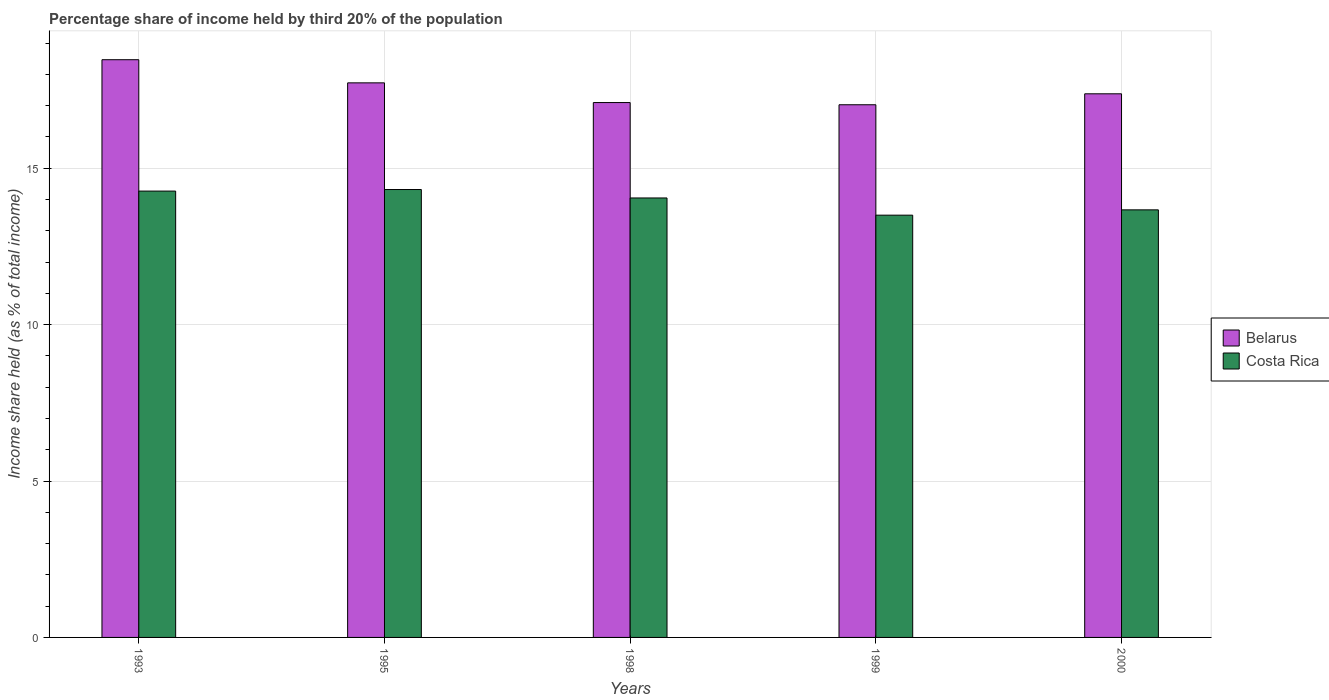How many different coloured bars are there?
Keep it short and to the point. 2. How many bars are there on the 3rd tick from the right?
Keep it short and to the point. 2. What is the label of the 3rd group of bars from the left?
Offer a very short reply. 1998. What is the share of income held by third 20% of the population in Belarus in 1998?
Ensure brevity in your answer.  17.1. Across all years, what is the maximum share of income held by third 20% of the population in Belarus?
Keep it short and to the point. 18.47. Across all years, what is the minimum share of income held by third 20% of the population in Costa Rica?
Ensure brevity in your answer.  13.5. In which year was the share of income held by third 20% of the population in Belarus maximum?
Your answer should be compact. 1993. What is the total share of income held by third 20% of the population in Belarus in the graph?
Give a very brief answer. 87.71. What is the difference between the share of income held by third 20% of the population in Costa Rica in 1993 and that in 1999?
Provide a short and direct response. 0.77. What is the difference between the share of income held by third 20% of the population in Belarus in 1993 and the share of income held by third 20% of the population in Costa Rica in 1995?
Provide a short and direct response. 4.15. What is the average share of income held by third 20% of the population in Belarus per year?
Keep it short and to the point. 17.54. In the year 1999, what is the difference between the share of income held by third 20% of the population in Belarus and share of income held by third 20% of the population in Costa Rica?
Make the answer very short. 3.53. What is the ratio of the share of income held by third 20% of the population in Belarus in 1993 to that in 1998?
Give a very brief answer. 1.08. Is the share of income held by third 20% of the population in Belarus in 1999 less than that in 2000?
Offer a very short reply. Yes. Is the difference between the share of income held by third 20% of the population in Belarus in 1993 and 1998 greater than the difference between the share of income held by third 20% of the population in Costa Rica in 1993 and 1998?
Provide a short and direct response. Yes. What is the difference between the highest and the second highest share of income held by third 20% of the population in Belarus?
Your answer should be compact. 0.74. What is the difference between the highest and the lowest share of income held by third 20% of the population in Belarus?
Your answer should be very brief. 1.44. In how many years, is the share of income held by third 20% of the population in Belarus greater than the average share of income held by third 20% of the population in Belarus taken over all years?
Make the answer very short. 2. Is the sum of the share of income held by third 20% of the population in Costa Rica in 1993 and 2000 greater than the maximum share of income held by third 20% of the population in Belarus across all years?
Your answer should be compact. Yes. What does the 1st bar from the left in 2000 represents?
Give a very brief answer. Belarus. What does the 2nd bar from the right in 1993 represents?
Offer a terse response. Belarus. How many bars are there?
Your answer should be compact. 10. What is the difference between two consecutive major ticks on the Y-axis?
Ensure brevity in your answer.  5. Does the graph contain grids?
Give a very brief answer. Yes. What is the title of the graph?
Make the answer very short. Percentage share of income held by third 20% of the population. What is the label or title of the Y-axis?
Offer a terse response. Income share held (as % of total income). What is the Income share held (as % of total income) in Belarus in 1993?
Your answer should be very brief. 18.47. What is the Income share held (as % of total income) in Costa Rica in 1993?
Provide a succinct answer. 14.27. What is the Income share held (as % of total income) of Belarus in 1995?
Your response must be concise. 17.73. What is the Income share held (as % of total income) in Costa Rica in 1995?
Give a very brief answer. 14.32. What is the Income share held (as % of total income) in Costa Rica in 1998?
Offer a terse response. 14.05. What is the Income share held (as % of total income) in Belarus in 1999?
Offer a very short reply. 17.03. What is the Income share held (as % of total income) in Belarus in 2000?
Your response must be concise. 17.38. What is the Income share held (as % of total income) of Costa Rica in 2000?
Give a very brief answer. 13.67. Across all years, what is the maximum Income share held (as % of total income) of Belarus?
Give a very brief answer. 18.47. Across all years, what is the maximum Income share held (as % of total income) in Costa Rica?
Your answer should be compact. 14.32. Across all years, what is the minimum Income share held (as % of total income) of Belarus?
Your answer should be compact. 17.03. Across all years, what is the minimum Income share held (as % of total income) of Costa Rica?
Provide a short and direct response. 13.5. What is the total Income share held (as % of total income) in Belarus in the graph?
Your answer should be very brief. 87.71. What is the total Income share held (as % of total income) in Costa Rica in the graph?
Your response must be concise. 69.81. What is the difference between the Income share held (as % of total income) of Belarus in 1993 and that in 1995?
Provide a short and direct response. 0.74. What is the difference between the Income share held (as % of total income) of Belarus in 1993 and that in 1998?
Your response must be concise. 1.37. What is the difference between the Income share held (as % of total income) of Costa Rica in 1993 and that in 1998?
Provide a short and direct response. 0.22. What is the difference between the Income share held (as % of total income) of Belarus in 1993 and that in 1999?
Your response must be concise. 1.44. What is the difference between the Income share held (as % of total income) of Costa Rica in 1993 and that in 1999?
Offer a terse response. 0.77. What is the difference between the Income share held (as % of total income) of Belarus in 1993 and that in 2000?
Ensure brevity in your answer.  1.09. What is the difference between the Income share held (as % of total income) in Belarus in 1995 and that in 1998?
Ensure brevity in your answer.  0.63. What is the difference between the Income share held (as % of total income) in Costa Rica in 1995 and that in 1998?
Offer a terse response. 0.27. What is the difference between the Income share held (as % of total income) of Belarus in 1995 and that in 1999?
Offer a terse response. 0.7. What is the difference between the Income share held (as % of total income) of Costa Rica in 1995 and that in 1999?
Keep it short and to the point. 0.82. What is the difference between the Income share held (as % of total income) of Belarus in 1995 and that in 2000?
Your answer should be very brief. 0.35. What is the difference between the Income share held (as % of total income) in Costa Rica in 1995 and that in 2000?
Provide a short and direct response. 0.65. What is the difference between the Income share held (as % of total income) of Belarus in 1998 and that in 1999?
Provide a short and direct response. 0.07. What is the difference between the Income share held (as % of total income) in Costa Rica in 1998 and that in 1999?
Your response must be concise. 0.55. What is the difference between the Income share held (as % of total income) of Belarus in 1998 and that in 2000?
Offer a very short reply. -0.28. What is the difference between the Income share held (as % of total income) in Costa Rica in 1998 and that in 2000?
Your response must be concise. 0.38. What is the difference between the Income share held (as % of total income) in Belarus in 1999 and that in 2000?
Offer a terse response. -0.35. What is the difference between the Income share held (as % of total income) in Costa Rica in 1999 and that in 2000?
Your answer should be very brief. -0.17. What is the difference between the Income share held (as % of total income) in Belarus in 1993 and the Income share held (as % of total income) in Costa Rica in 1995?
Your response must be concise. 4.15. What is the difference between the Income share held (as % of total income) in Belarus in 1993 and the Income share held (as % of total income) in Costa Rica in 1998?
Make the answer very short. 4.42. What is the difference between the Income share held (as % of total income) of Belarus in 1993 and the Income share held (as % of total income) of Costa Rica in 1999?
Your answer should be very brief. 4.97. What is the difference between the Income share held (as % of total income) of Belarus in 1993 and the Income share held (as % of total income) of Costa Rica in 2000?
Give a very brief answer. 4.8. What is the difference between the Income share held (as % of total income) of Belarus in 1995 and the Income share held (as % of total income) of Costa Rica in 1998?
Give a very brief answer. 3.68. What is the difference between the Income share held (as % of total income) in Belarus in 1995 and the Income share held (as % of total income) in Costa Rica in 1999?
Give a very brief answer. 4.23. What is the difference between the Income share held (as % of total income) in Belarus in 1995 and the Income share held (as % of total income) in Costa Rica in 2000?
Your answer should be compact. 4.06. What is the difference between the Income share held (as % of total income) of Belarus in 1998 and the Income share held (as % of total income) of Costa Rica in 2000?
Offer a very short reply. 3.43. What is the difference between the Income share held (as % of total income) of Belarus in 1999 and the Income share held (as % of total income) of Costa Rica in 2000?
Offer a terse response. 3.36. What is the average Income share held (as % of total income) of Belarus per year?
Give a very brief answer. 17.54. What is the average Income share held (as % of total income) of Costa Rica per year?
Ensure brevity in your answer.  13.96. In the year 1995, what is the difference between the Income share held (as % of total income) of Belarus and Income share held (as % of total income) of Costa Rica?
Give a very brief answer. 3.41. In the year 1998, what is the difference between the Income share held (as % of total income) in Belarus and Income share held (as % of total income) in Costa Rica?
Offer a very short reply. 3.05. In the year 1999, what is the difference between the Income share held (as % of total income) of Belarus and Income share held (as % of total income) of Costa Rica?
Ensure brevity in your answer.  3.53. In the year 2000, what is the difference between the Income share held (as % of total income) in Belarus and Income share held (as % of total income) in Costa Rica?
Offer a very short reply. 3.71. What is the ratio of the Income share held (as % of total income) in Belarus in 1993 to that in 1995?
Give a very brief answer. 1.04. What is the ratio of the Income share held (as % of total income) in Costa Rica in 1993 to that in 1995?
Offer a terse response. 1. What is the ratio of the Income share held (as % of total income) of Belarus in 1993 to that in 1998?
Give a very brief answer. 1.08. What is the ratio of the Income share held (as % of total income) of Costa Rica in 1993 to that in 1998?
Provide a short and direct response. 1.02. What is the ratio of the Income share held (as % of total income) in Belarus in 1993 to that in 1999?
Keep it short and to the point. 1.08. What is the ratio of the Income share held (as % of total income) in Costa Rica in 1993 to that in 1999?
Keep it short and to the point. 1.06. What is the ratio of the Income share held (as % of total income) in Belarus in 1993 to that in 2000?
Provide a short and direct response. 1.06. What is the ratio of the Income share held (as % of total income) in Costa Rica in 1993 to that in 2000?
Your answer should be very brief. 1.04. What is the ratio of the Income share held (as % of total income) in Belarus in 1995 to that in 1998?
Your answer should be compact. 1.04. What is the ratio of the Income share held (as % of total income) of Costa Rica in 1995 to that in 1998?
Provide a succinct answer. 1.02. What is the ratio of the Income share held (as % of total income) of Belarus in 1995 to that in 1999?
Your answer should be very brief. 1.04. What is the ratio of the Income share held (as % of total income) in Costa Rica in 1995 to that in 1999?
Give a very brief answer. 1.06. What is the ratio of the Income share held (as % of total income) of Belarus in 1995 to that in 2000?
Ensure brevity in your answer.  1.02. What is the ratio of the Income share held (as % of total income) of Costa Rica in 1995 to that in 2000?
Offer a terse response. 1.05. What is the ratio of the Income share held (as % of total income) in Belarus in 1998 to that in 1999?
Ensure brevity in your answer.  1. What is the ratio of the Income share held (as % of total income) of Costa Rica in 1998 to that in 1999?
Your answer should be very brief. 1.04. What is the ratio of the Income share held (as % of total income) in Belarus in 1998 to that in 2000?
Make the answer very short. 0.98. What is the ratio of the Income share held (as % of total income) of Costa Rica in 1998 to that in 2000?
Your response must be concise. 1.03. What is the ratio of the Income share held (as % of total income) of Belarus in 1999 to that in 2000?
Your answer should be very brief. 0.98. What is the ratio of the Income share held (as % of total income) in Costa Rica in 1999 to that in 2000?
Your answer should be compact. 0.99. What is the difference between the highest and the second highest Income share held (as % of total income) in Belarus?
Your response must be concise. 0.74. What is the difference between the highest and the second highest Income share held (as % of total income) of Costa Rica?
Make the answer very short. 0.05. What is the difference between the highest and the lowest Income share held (as % of total income) in Belarus?
Keep it short and to the point. 1.44. What is the difference between the highest and the lowest Income share held (as % of total income) of Costa Rica?
Give a very brief answer. 0.82. 